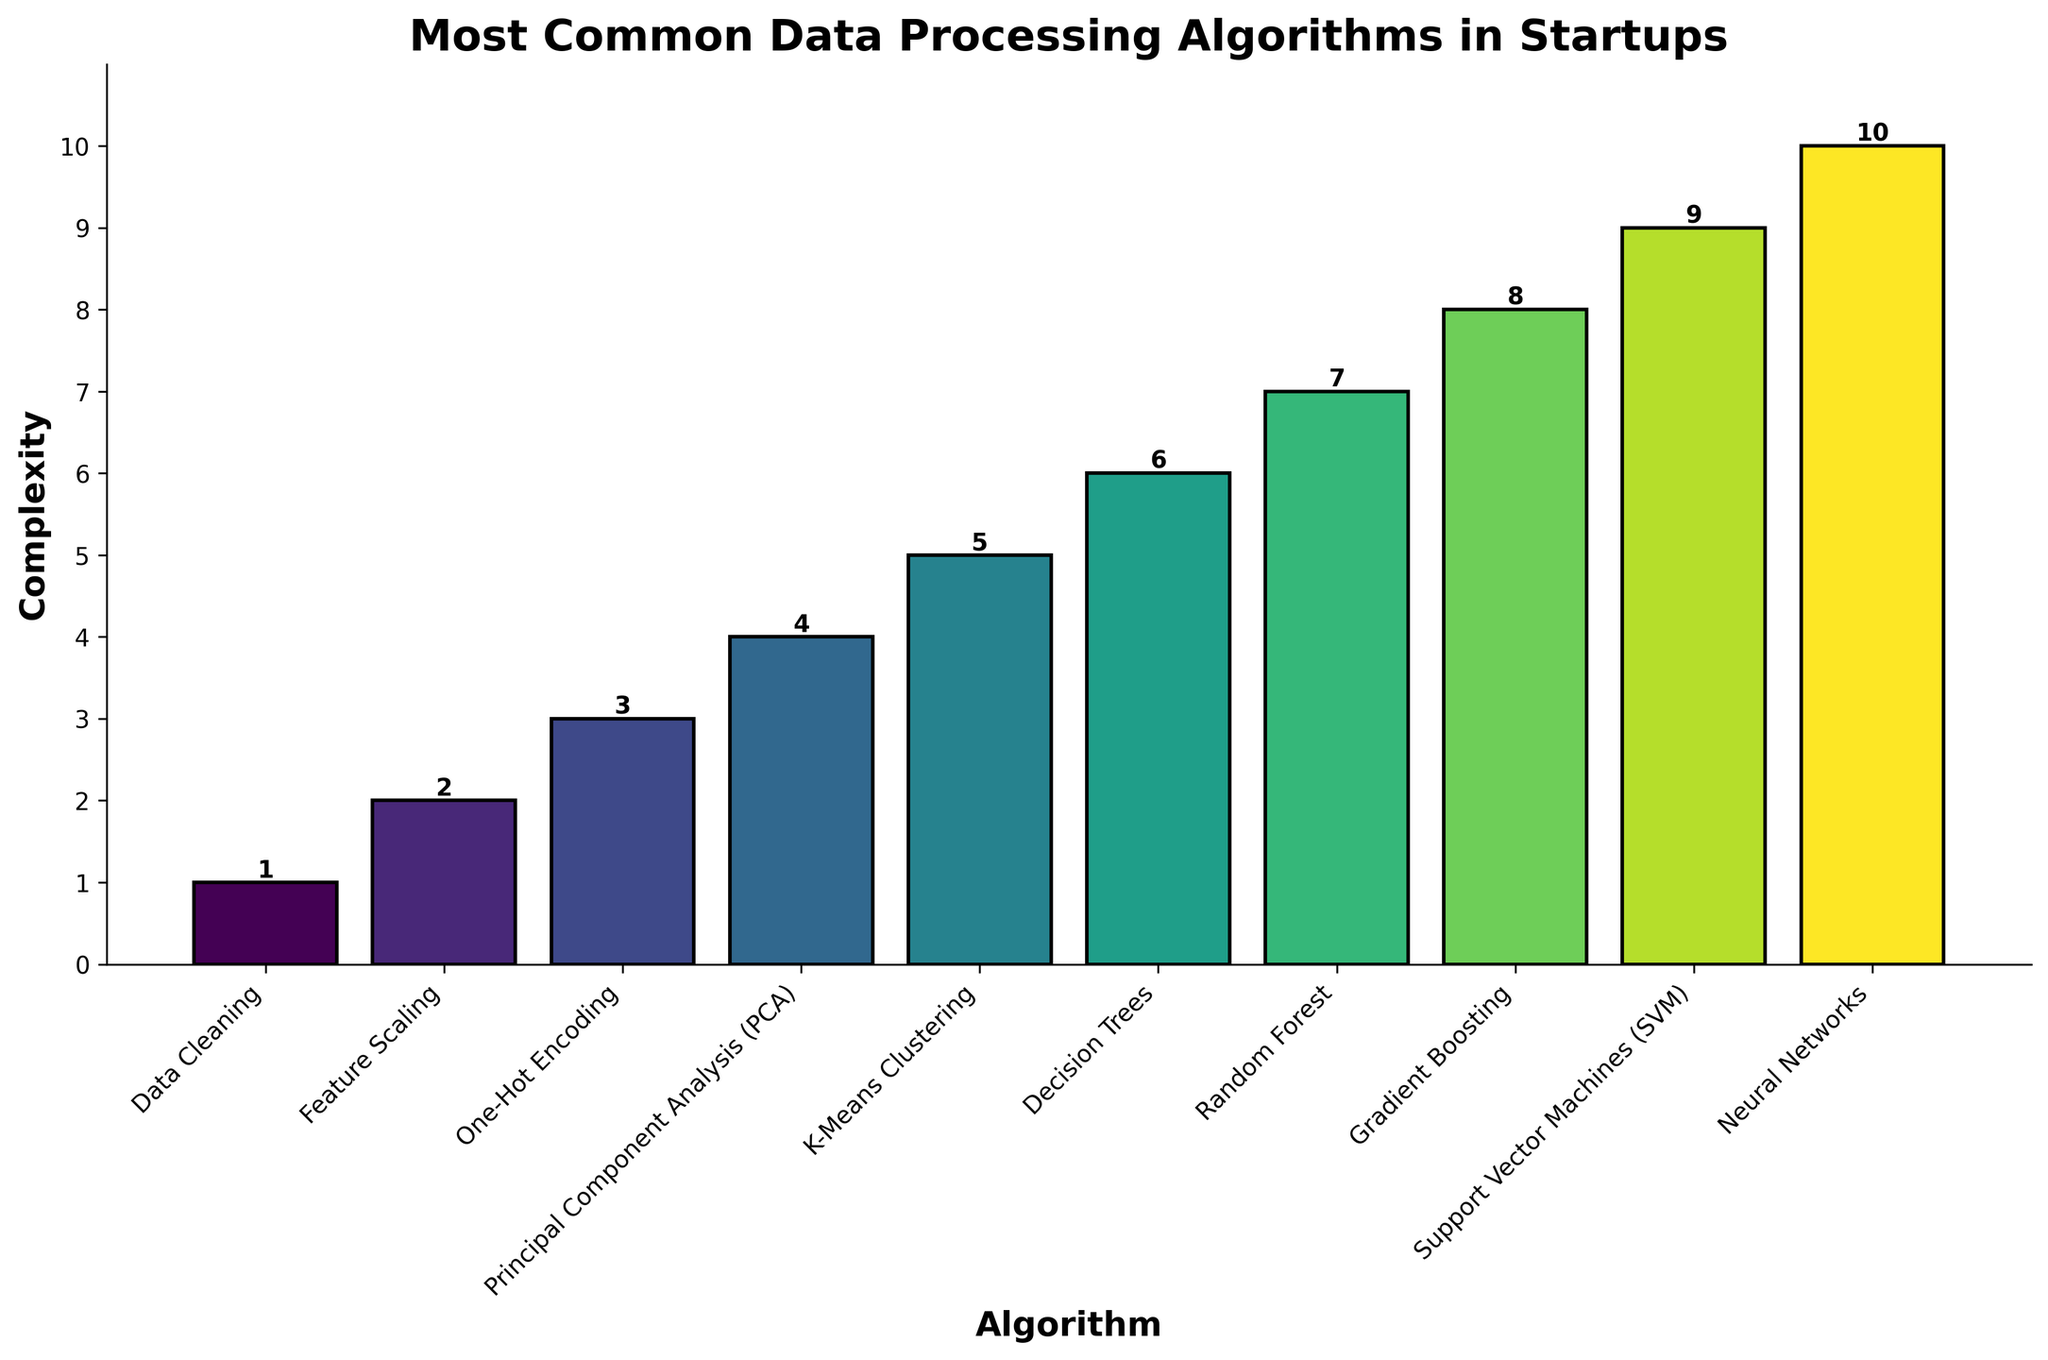Which algorithm has the highest complexity? Look at the bar with the maximum height. The tallest bar corresponds to "Neural Networks".
Answer: Neural Networks What is the average complexity of the first three algorithms listed? The complexities of the first three algorithms (Data Cleaning, Feature Scaling, and One-Hot Encoding) are 1, 2, and 3, respectively. Sum these values (1 + 2 + 3 = 6) and divide by 3. So, the average is 6/3 = 2.
Answer: 2 Which algorithm is exactly in the middle in terms of complexity? There are 10 algorithms, so the middle one is the 5th when sorted by complexity. The 5th algorithm listed is "K-Means Clustering".
Answer: K-Means Clustering How does the complexity of Decision Trees compare to K-Means Clustering? Compare the heights of the bars for Decision Trees and K-Means Clustering. Decision Trees (6) is more complex than K-Means Clustering (5).
Answer: Decision Trees is more complex What is the sum of the complexities of Data Cleaning and Support Vector Machines (SVM)? The complexities of Data Cleaning and SVM are 1 and 9, respectively. Sum these values (1 + 9 = 10).
Answer: 10 Which algorithm has a complexity of 4? Find the bar with a height corresponding to a complexity of 4. This bar represents "Principal Component Analysis (PCA)".
Answer: Principal Component Analysis (PCA) What is the difference in complexity between Random Forest and Neural Networks? The complexity of Random Forest is 7, and Neural Networks is 10. Subtract these values (10 - 7 = 3).
Answer: 3 What is the total complexity for the algorithms with complexities less than 5? The complexities less than 5 are 1 (Data Cleaning), 2 (Feature Scaling), 3 (One-Hot Encoding), and 4 (PCA). Sum these values (1 + 2 + 3 + 4 = 10).
Answer: 10 Which two algorithms have the smallest and largest complexities respectively? The algorithm with the smallest complexity is Data Cleaning (1), and the algorithm with the largest complexity is Neural Networks (10).
Answer: Data Cleaning and Neural Networks What visual feature makes it easiest to differentiate the bars? The bars are differentiated by their heights and colors. The height indicates complexity; different colors help distinguish the bars visually.
Answer: Heights and colors 